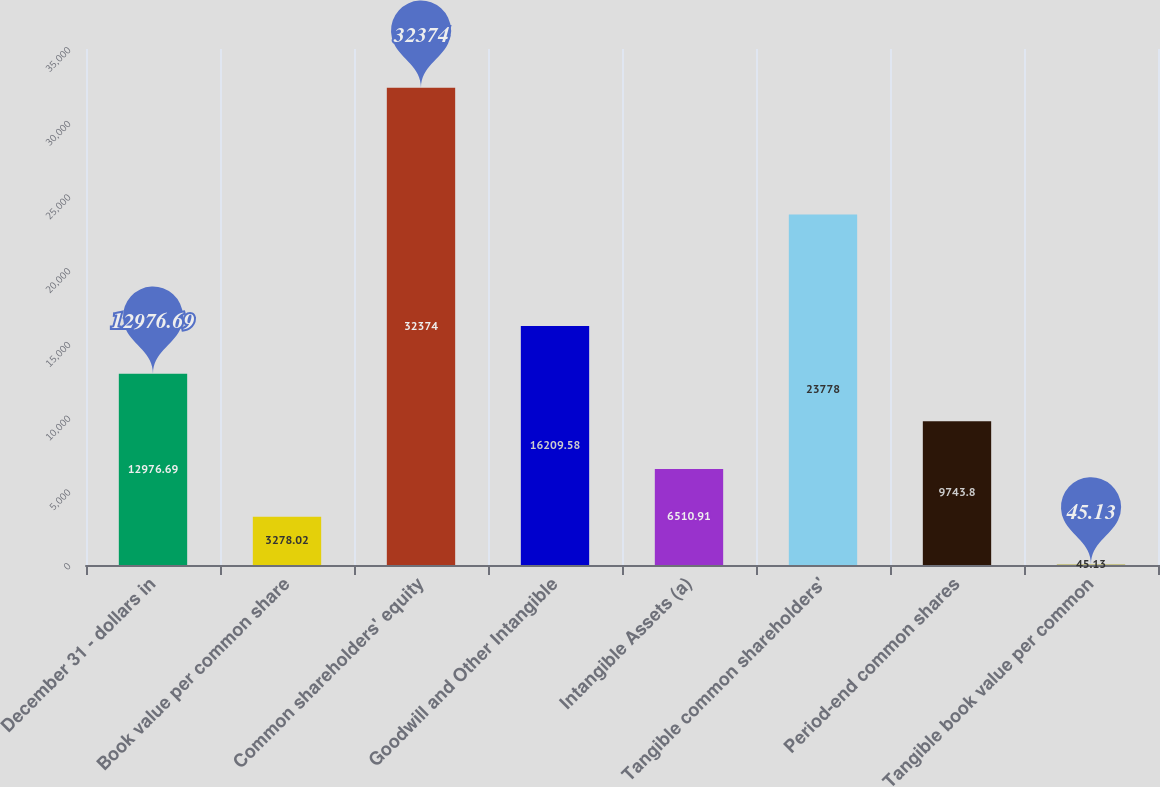Convert chart. <chart><loc_0><loc_0><loc_500><loc_500><bar_chart><fcel>December 31 - dollars in<fcel>Book value per common share<fcel>Common shareholders' equity<fcel>Goodwill and Other Intangible<fcel>Intangible Assets (a)<fcel>Tangible common shareholders'<fcel>Period-end common shares<fcel>Tangible book value per common<nl><fcel>12976.7<fcel>3278.02<fcel>32374<fcel>16209.6<fcel>6510.91<fcel>23778<fcel>9743.8<fcel>45.13<nl></chart> 